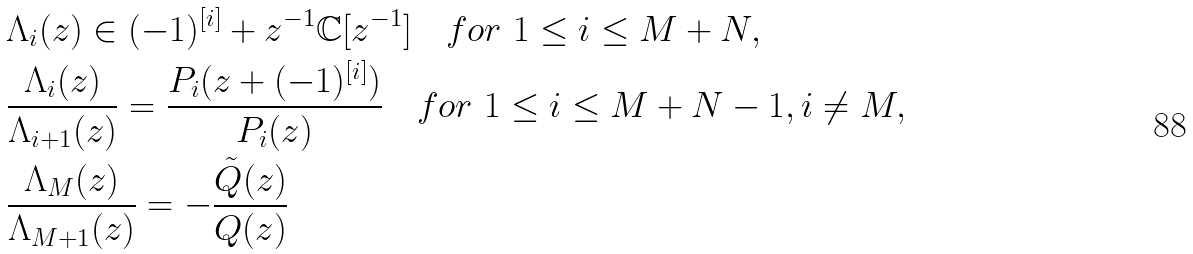<formula> <loc_0><loc_0><loc_500><loc_500>& \Lambda _ { i } ( z ) \in ( - 1 ) ^ { [ i ] } + z ^ { - 1 } \mathbb { C } [ z ^ { - 1 } ] \quad f o r \ 1 \leq i \leq M + N , \\ & \frac { \Lambda _ { i } ( z ) } { \Lambda _ { i + 1 } ( z ) } = \frac { P _ { i } ( z + ( - 1 ) ^ { [ i ] } ) } { P _ { i } ( z ) } \quad f o r \ 1 \leq i \leq M + N - 1 , i \neq M , \\ & \frac { \Lambda _ { M } ( z ) } { \Lambda _ { M + 1 } ( z ) } = - \frac { \tilde { Q } ( z ) } { Q ( z ) }</formula> 